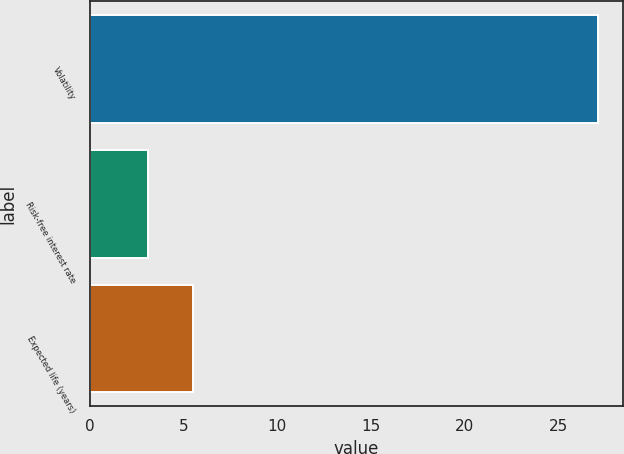<chart> <loc_0><loc_0><loc_500><loc_500><bar_chart><fcel>Volatility<fcel>Risk-free interest rate<fcel>Expected life (years)<nl><fcel>27.1<fcel>3.1<fcel>5.5<nl></chart> 